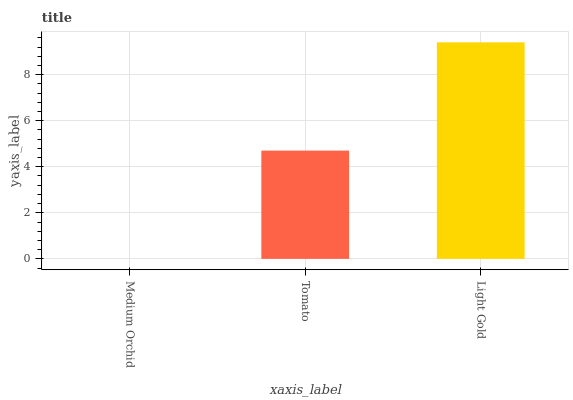Is Medium Orchid the minimum?
Answer yes or no. Yes. Is Light Gold the maximum?
Answer yes or no. Yes. Is Tomato the minimum?
Answer yes or no. No. Is Tomato the maximum?
Answer yes or no. No. Is Tomato greater than Medium Orchid?
Answer yes or no. Yes. Is Medium Orchid less than Tomato?
Answer yes or no. Yes. Is Medium Orchid greater than Tomato?
Answer yes or no. No. Is Tomato less than Medium Orchid?
Answer yes or no. No. Is Tomato the high median?
Answer yes or no. Yes. Is Tomato the low median?
Answer yes or no. Yes. Is Medium Orchid the high median?
Answer yes or no. No. Is Light Gold the low median?
Answer yes or no. No. 